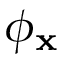<formula> <loc_0><loc_0><loc_500><loc_500>\phi _ { x }</formula> 